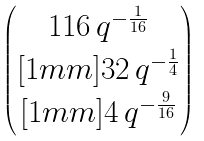Convert formula to latex. <formula><loc_0><loc_0><loc_500><loc_500>\begin{pmatrix} 1 1 6 \, q ^ { - \frac { 1 } { 1 6 } } \\ [ 1 m m ] 3 2 \, q ^ { - \frac { 1 } { 4 } } \\ [ 1 m m ] 4 \, q ^ { - \frac { 9 } { 1 6 } } \end{pmatrix}</formula> 